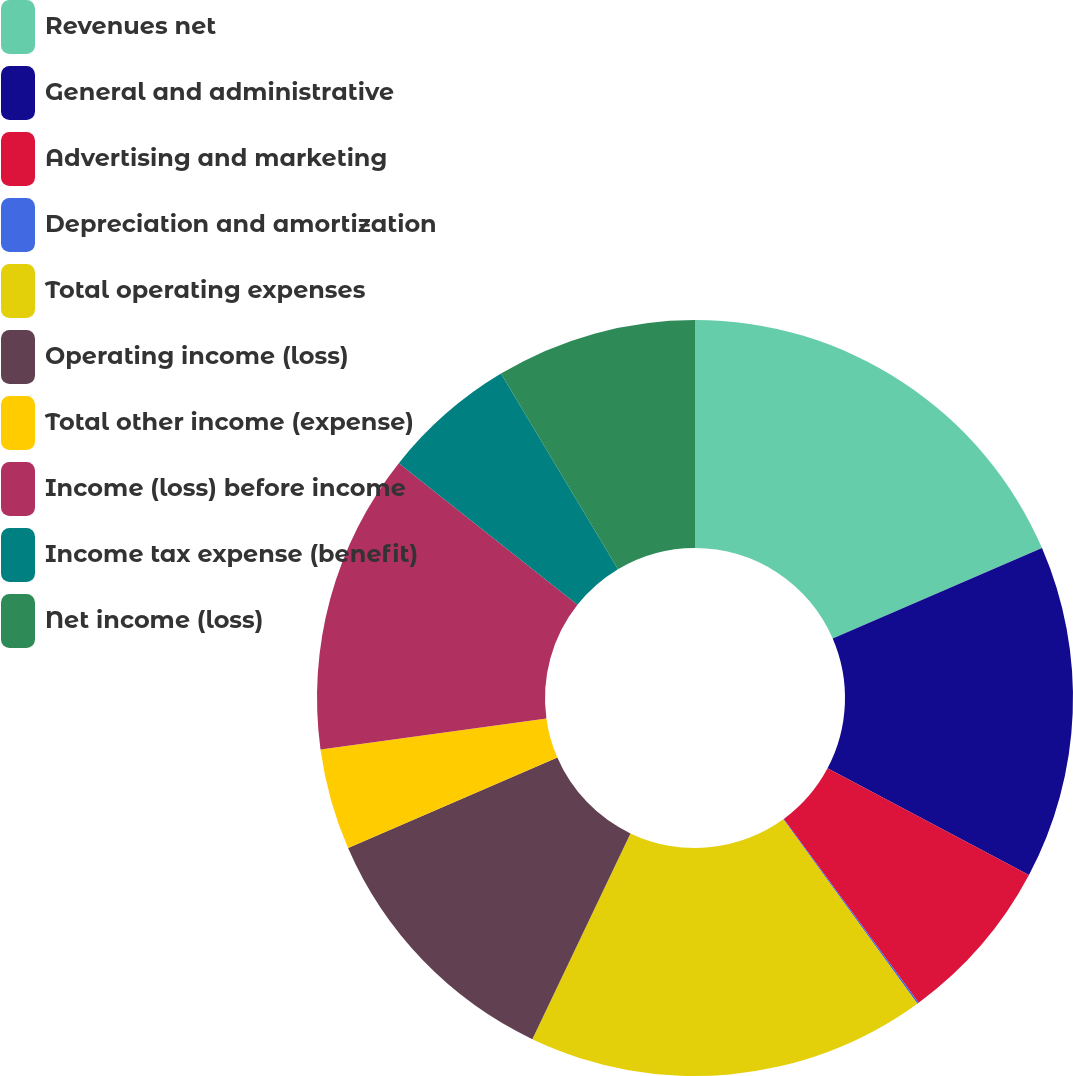Convert chart to OTSL. <chart><loc_0><loc_0><loc_500><loc_500><pie_chart><fcel>Revenues net<fcel>General and administrative<fcel>Advertising and marketing<fcel>Depreciation and amortization<fcel>Total operating expenses<fcel>Operating income (loss)<fcel>Total other income (expense)<fcel>Income (loss) before income<fcel>Income tax expense (benefit)<fcel>Net income (loss)<nl><fcel>18.51%<fcel>14.25%<fcel>7.16%<fcel>0.07%<fcel>17.09%<fcel>11.42%<fcel>4.33%<fcel>12.84%<fcel>5.75%<fcel>8.58%<nl></chart> 